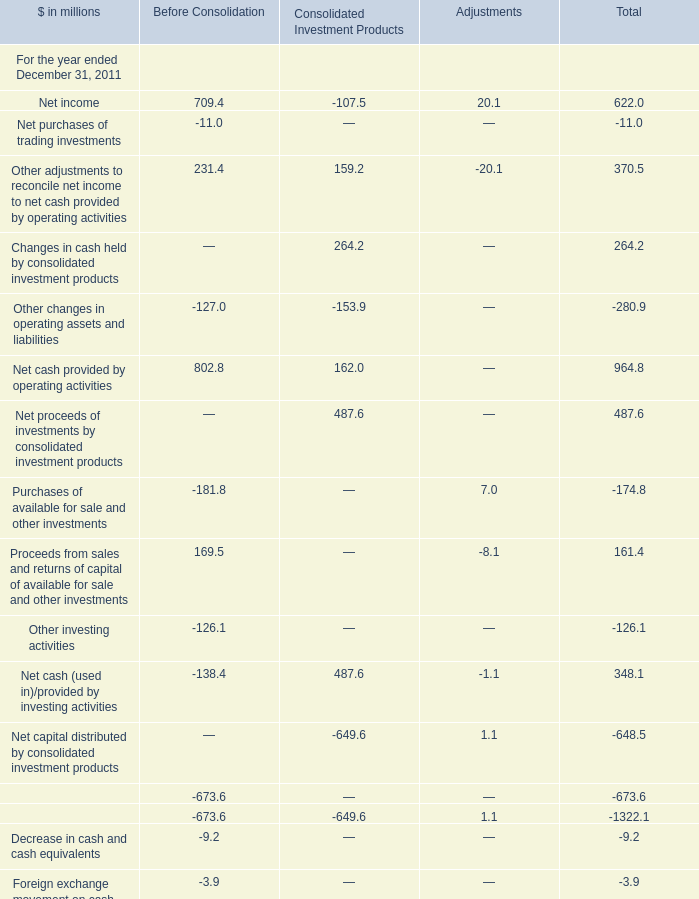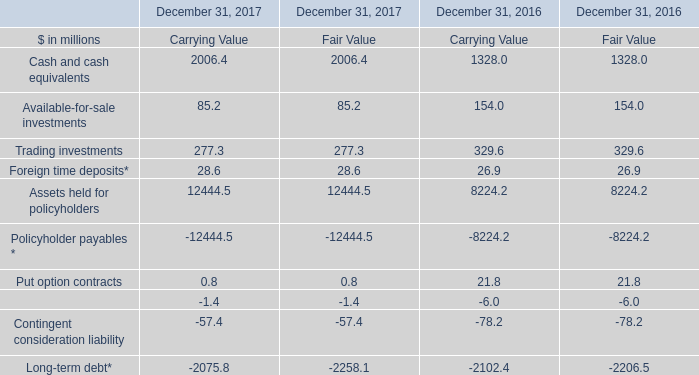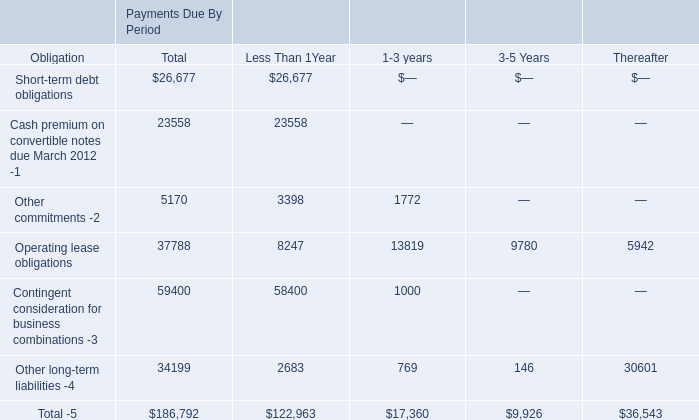What is the sum of Net cash provided by operating activities for Before Consolidation and Trading investments of Fair Value 2017? (in million) 
Computations: (802.8 + 277.3)
Answer: 1080.1. 